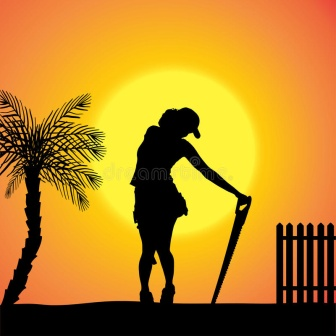Can you describe the mood of the scene? The mood of the scene is one of tranquil beauty and peaceful introspection. The warm colors of the sunset create a calming atmosphere, while the silhouetted figure leaning on the shovel adds an element of quiet rest after a day's hard work. The serene setting is complemented by the stillness of the palm tree and the fence, giving a sense of stillness and solitude, evoking feelings of relaxation and reflection. 